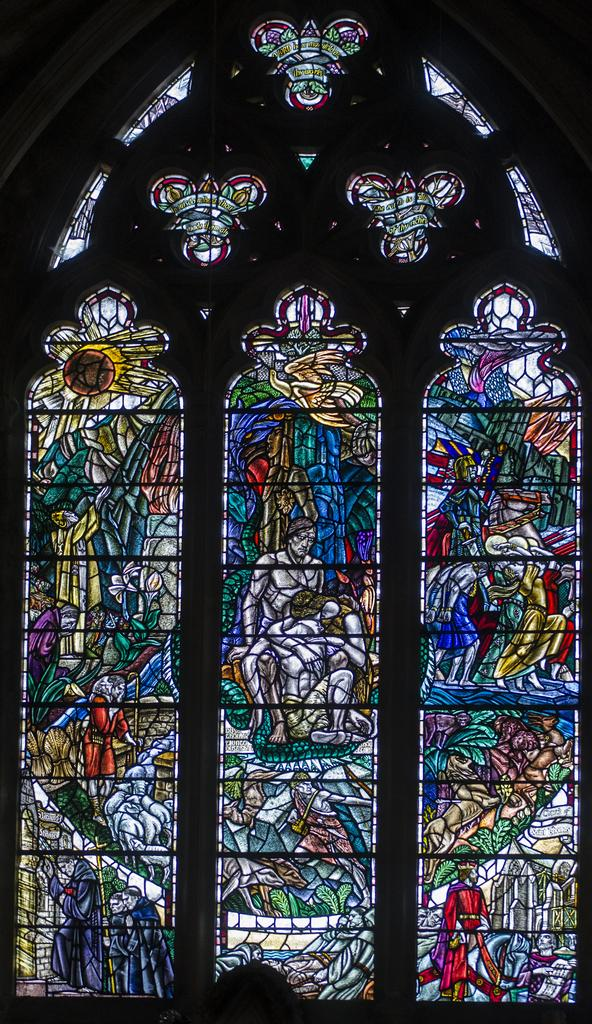What type of glass is present in the image? There is stained glass in the image. What colors can be seen in the stained glass? The stained glass contains blue, red, yellow, and green colors. Can you see a train passing through the stained glass in the image? There is no train present in the image; it only features stained glass with various colors. 